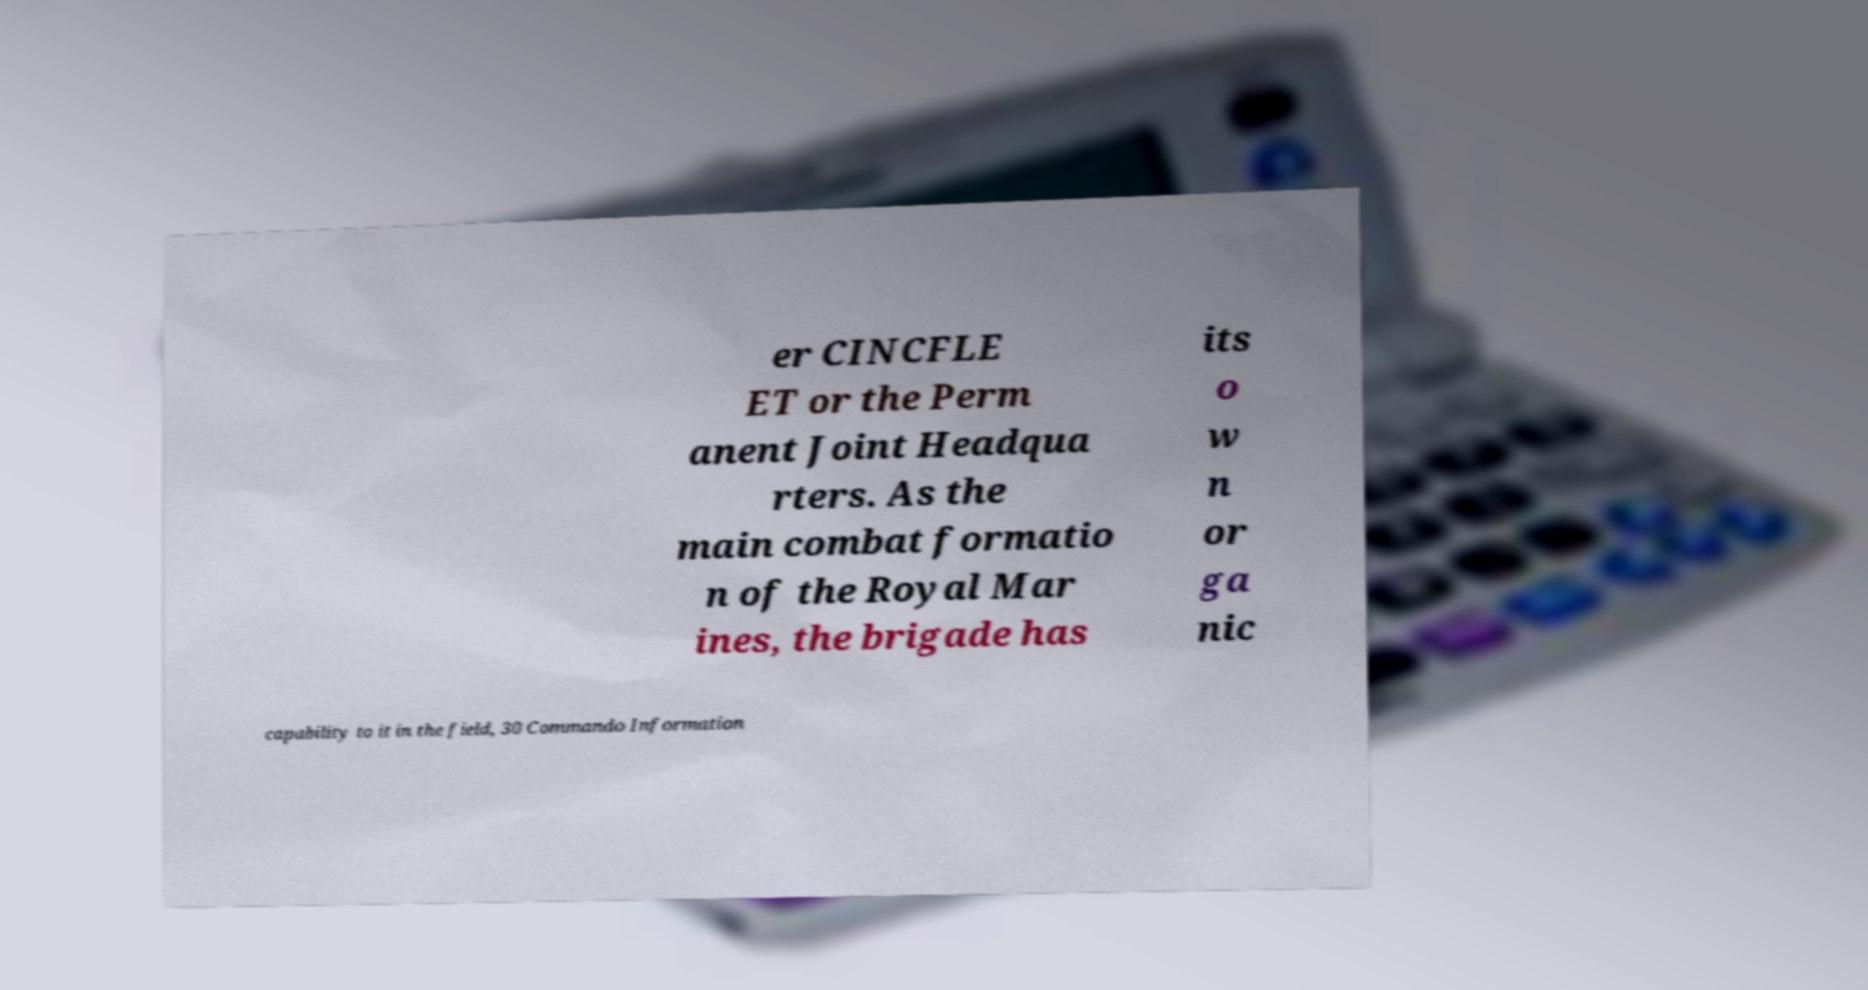Could you assist in decoding the text presented in this image and type it out clearly? er CINCFLE ET or the Perm anent Joint Headqua rters. As the main combat formatio n of the Royal Mar ines, the brigade has its o w n or ga nic capability to it in the field, 30 Commando Information 